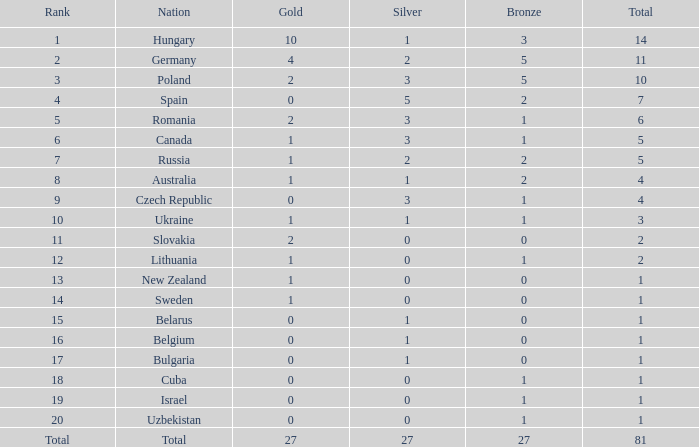Which Rank has a Bronze of 1, and a Nation of lithuania? 12.0. 